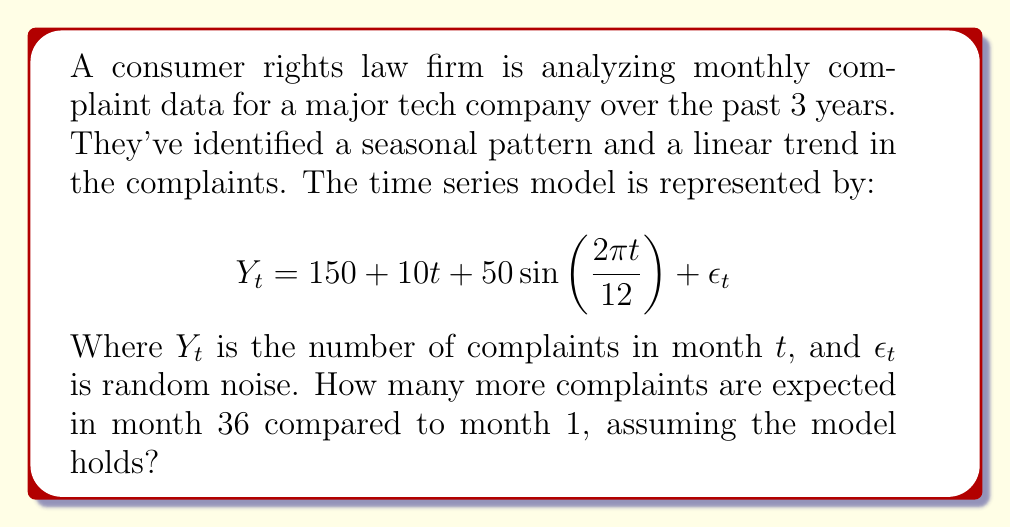Can you solve this math problem? To solve this problem, we need to calculate the difference between the expected number of complaints in month 36 and month 1, ignoring the random noise term.

Step 1: Calculate $Y_1$ (ignoring $\epsilon_1$)
$$Y_1 = 150 + 10(1) + 50\sin(\frac{2\pi(1)}{12})$$
$$Y_1 = 160 + 50\sin(\frac{\pi}{6}) \approx 185$$

Step 2: Calculate $Y_{36}$ (ignoring $\epsilon_{36}$)
$$Y_{36} = 150 + 10(36) + 50\sin(\frac{2\pi(36)}{12})$$
$$Y_{36} = 510 + 50\sin(6\pi) = 510$$

Step 3: Calculate the difference
$$Y_{36} - Y_1 = 510 - 185 = 325$$

Therefore, 325 more complaints are expected in month 36 compared to month 1.
Answer: 325 complaints 